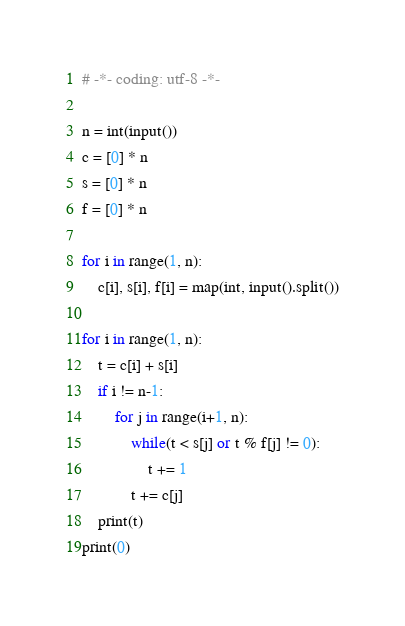<code> <loc_0><loc_0><loc_500><loc_500><_Python_># -*- coding: utf-8 -*-

n = int(input())
c = [0] * n
s = [0] * n
f = [0] * n

for i in range(1, n):
    c[i], s[i], f[i] = map(int, input().split())

for i in range(1, n):
    t = c[i] + s[i]
    if i != n-1:
        for j in range(i+1, n):
            while(t < s[j] or t % f[j] != 0):
                t += 1
            t += c[j]
    print(t)
print(0)
</code> 